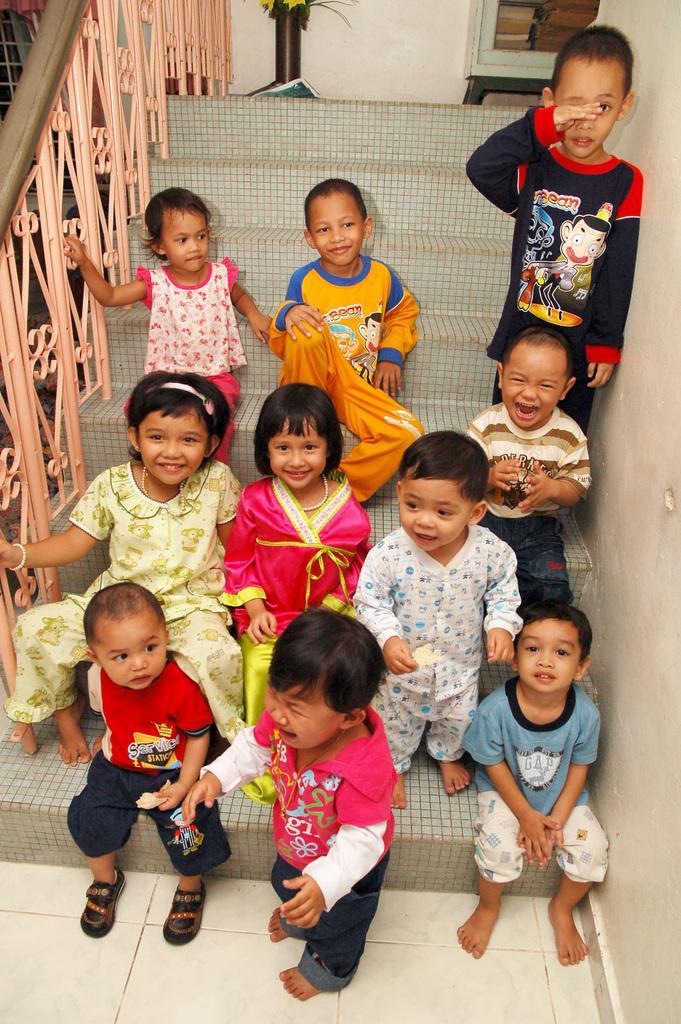Describe this image in one or two sentences. Here I can see few children sitting on the stairs, smiling and giving pose for the picture and also few children are standing. At the bottom one child is standing facing towards the left side and crying. On the right side there is a wall and on the left side there is a handrail. In the background there is a flower vase and a small table placed on the floor. At the top there is a window. 